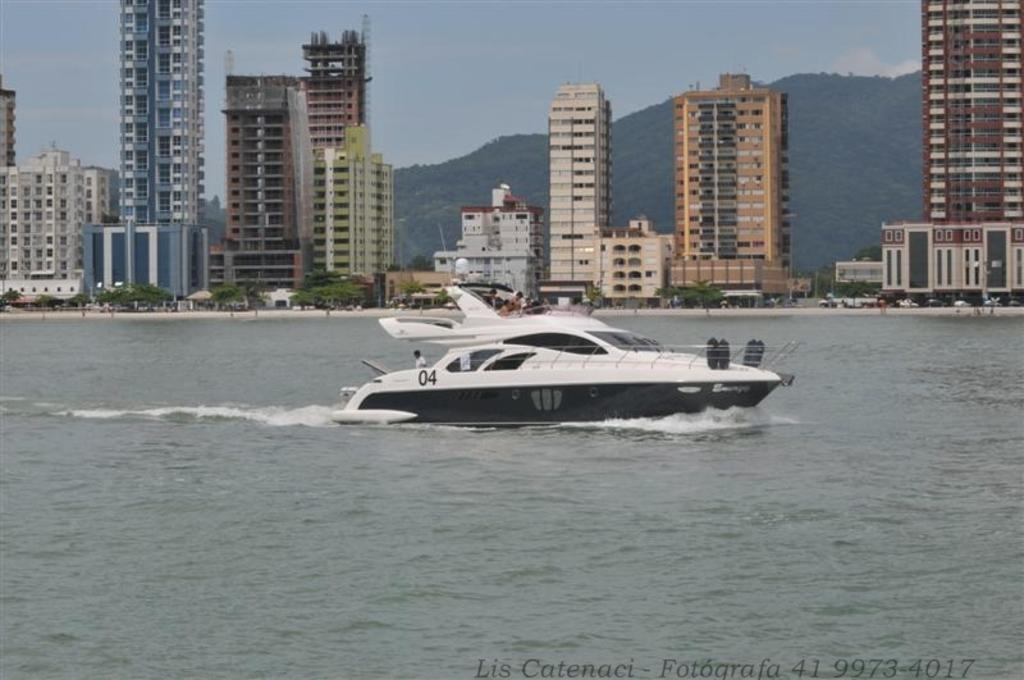What is the main element present in the image? There is water in the image. What can be seen in the middle of the water? There is a black and white color boat in the middle of the image. What is visible in the background of the image? There are buildings in the background of the image. What is visible at the top of the image? The sky is visible at the top of the image. What type of substance is the goose made of in the image? There is no goose present in the image, so it is not possible to determine what substance it might be made of. 